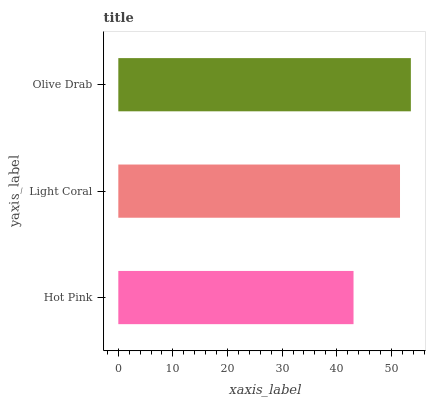Is Hot Pink the minimum?
Answer yes or no. Yes. Is Olive Drab the maximum?
Answer yes or no. Yes. Is Light Coral the minimum?
Answer yes or no. No. Is Light Coral the maximum?
Answer yes or no. No. Is Light Coral greater than Hot Pink?
Answer yes or no. Yes. Is Hot Pink less than Light Coral?
Answer yes or no. Yes. Is Hot Pink greater than Light Coral?
Answer yes or no. No. Is Light Coral less than Hot Pink?
Answer yes or no. No. Is Light Coral the high median?
Answer yes or no. Yes. Is Light Coral the low median?
Answer yes or no. Yes. Is Olive Drab the high median?
Answer yes or no. No. Is Hot Pink the low median?
Answer yes or no. No. 